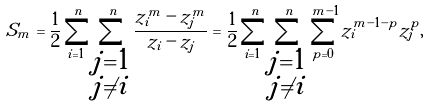<formula> <loc_0><loc_0><loc_500><loc_500>S _ { m } = \frac { 1 } { 2 } \sum _ { i = 1 } ^ { n } \sum _ { \substack { j = 1 \\ j \ne i } } ^ { n } \frac { z _ { i } ^ { m } - z _ { j } ^ { m } } { z _ { i } - z _ { j } } = \frac { 1 } { 2 } \sum _ { i = 1 } ^ { n } \sum _ { \substack { j = 1 \\ j \ne i } } ^ { n } \sum _ { p = 0 } ^ { m - 1 } z _ { i } ^ { m - 1 - p } z _ { j } ^ { p } ,</formula> 